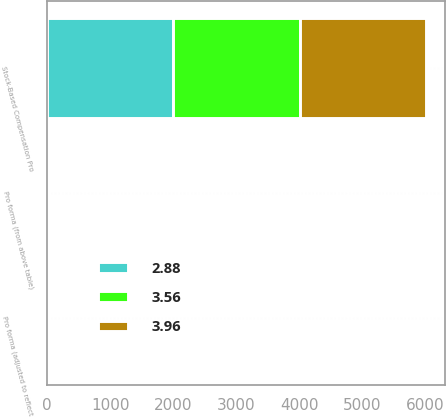<chart> <loc_0><loc_0><loc_500><loc_500><stacked_bar_chart><ecel><fcel>Stock-Based Compensation Pro<fcel>Pro forma (from above table)<fcel>Pro forma (adjusted to reflect<nl><fcel>3.96<fcel>2005<fcel>3.98<fcel>3.96<nl><fcel>3.56<fcel>2004<fcel>3.56<fcel>3.56<nl><fcel>2.88<fcel>2003<fcel>2.88<fcel>2.88<nl></chart> 